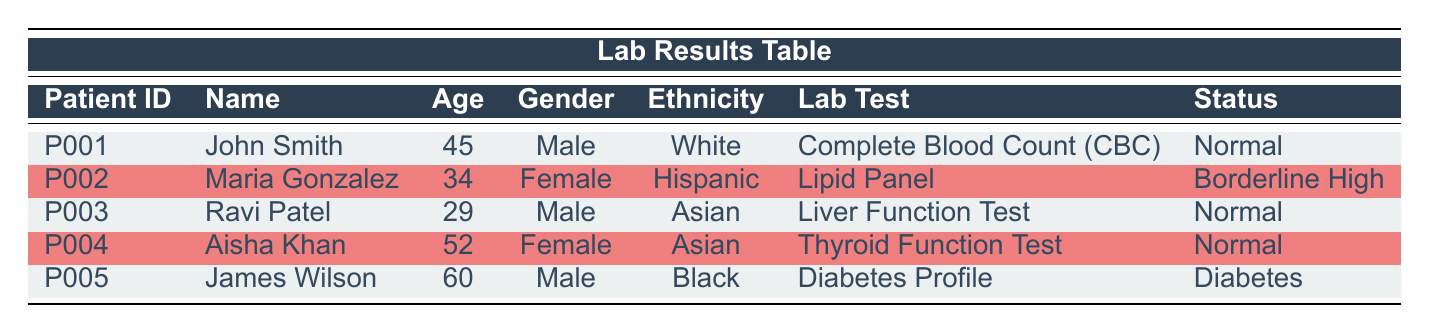What is the age of Maria Gonzalez? The table shows that Maria Gonzalez is listed under the PatientID P002. Looking at the corresponding Age column for this PatientID, her age is 34.
Answer: 34 How many patients have a "Normal" status? By reviewing the Status column, we can count the entries. There are three patients (John Smith, Ravi Patel, Aisha Khan) with "Normal" status.
Answer: 3 What is the ethnicity of James Wilson? Looking at the entry for James Wilson under PatientID P005, the Ethnicity column indicates that he is Black.
Answer: Black Which patient had a lab test done on May 12, 2023? Searching through the TestDate column, the entry on May 12, 2023, corresponds to Maria Gonzalez, listed under PatientID P002.
Answer: Maria Gonzalez What is the average age of all patients in the table? To find the average age, we first sum all the ages: 45 + 34 + 29 + 52 + 60 = 220. Then, we divide the sum by the number of patients (5): 220 / 5 = 44.
Answer: 44 Is there a patient with a "Diabetes" status? By examining the Status column, we find that James Wilson is listed with a "Diabetes" status. Therefore, the answer is yes.
Answer: Yes Which lab test had the highest age patient? The oldest patient listed is James Wilson at 60 years old, and he had a "Diabetes Profile" lab test done.
Answer: Diabetes Profile How many patients are male and have a "Normal" status? We need to filter for male patients with "Normal" status: John Smith and Ravi Patel fit this criterion. There are 2 such patients.
Answer: 2 What is the average LDL level from the lipid panel test? In the lipid panel test, only one patient, Maria Gonzalez, has an LDL value of 140. Since there's only one data point, the average is 140 / 1 = 140.
Answer: 140 